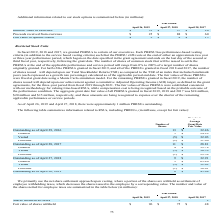From Netapp's financial document, Which years does the table provide Additional information related to the company's stock options? The document contains multiple relevant values: 2019, 2018, 2017. From the document: "April 26, 2019 April 27, 2018 April 28, 2017 April 26, 2019 April 27, 2018 April 28, 2017 April 26, 2019 April 27, 2018 April 28, 2017..." Also, What was the intrinsic value of exercises in 2019? According to the financial document, 31 (in millions). The relevant text states: "Intrinsic value of exercises $ 31 $ 37 $ 26..." Also, What were the Proceeds received from exercises in 2018? According to the financial document, 88 (in millions). The relevant text states: "Proceeds received from exercises $ 25 $ 88 $ 60..." Also, can you calculate: What was the change in Intrinsic value of exercises between 2017 and 2018? Based on the calculation: 37-26, the result is 11 (in millions). This is based on the information: "Intrinsic value of exercises $ 31 $ 37 $ 26 Intrinsic value of exercises $ 31 $ 37 $ 26..." The key data points involved are: 26, 37. Also, How many years did Proceeds received from exercises exceed $50 million? Counting the relevant items in the document: 2018, 2017, I find 2 instances. The key data points involved are: 2017, 2018. Also, can you calculate: What was the percentage change in the Fair value of options vested between 2018 and 2019? To answer this question, I need to perform calculations using the financial data. The calculation is: (2-8)/8, which equals -75 (percentage). This is based on the information: "April 26, 2019 April 27, 2018 April 28, 2017 April 26, 2019 April 27, 2018 April 28, 2017..." The key data points involved are: 2, 8. 